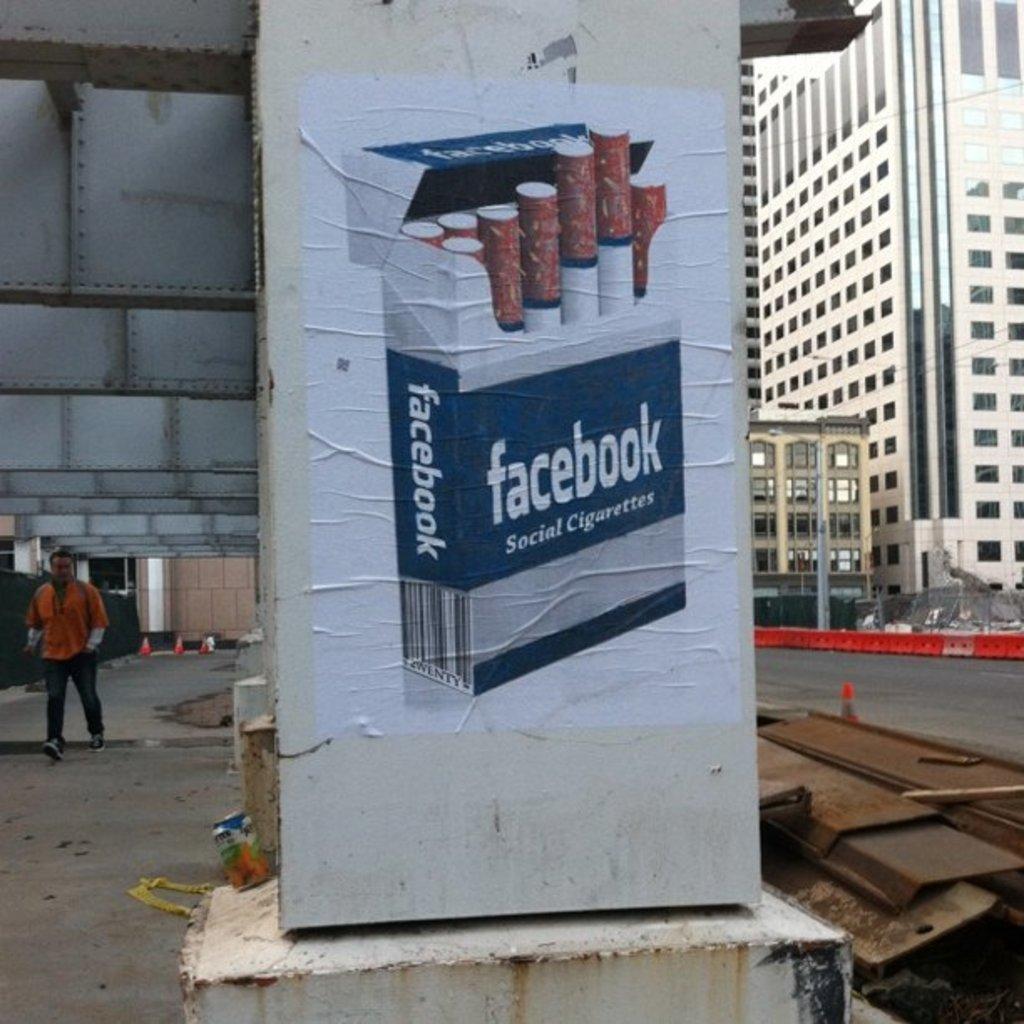Could you give a brief overview of what you see in this image? This is a poster, which is attached to the pillar. I can see the buildings with the windows. Here is a person walking. I think this is a flyover. These are the iron pillars. 